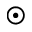Convert formula to latex. <formula><loc_0><loc_0><loc_500><loc_500>\odot</formula> 